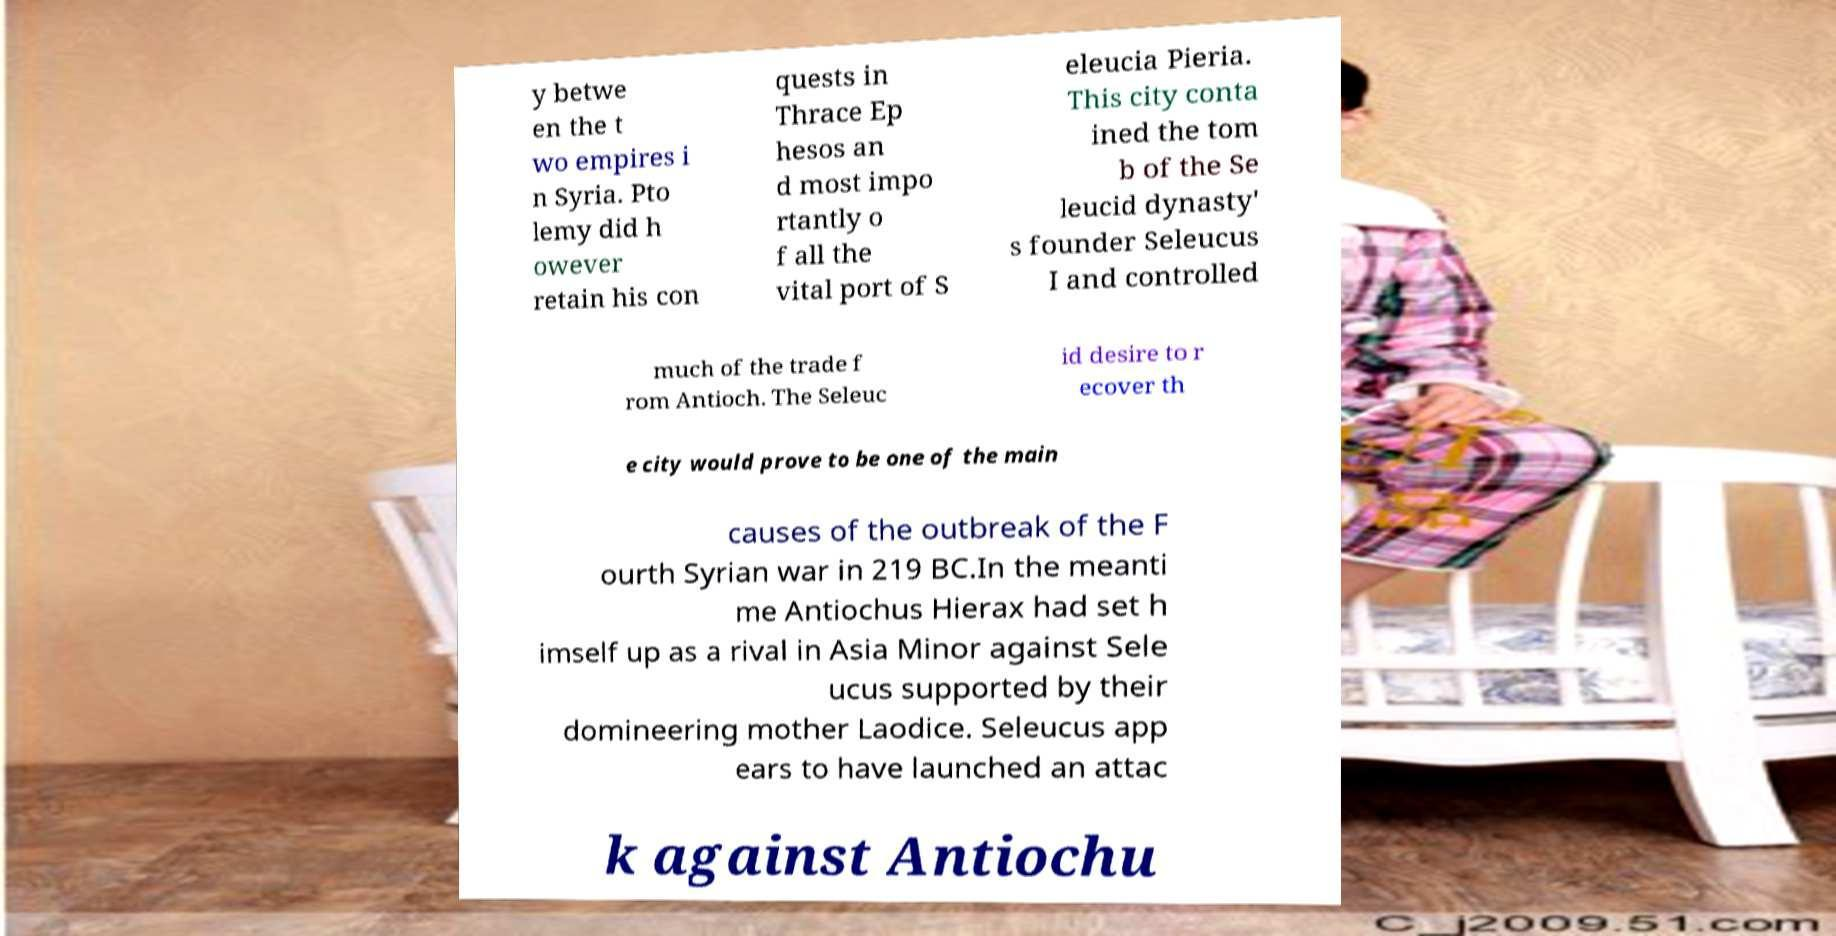There's text embedded in this image that I need extracted. Can you transcribe it verbatim? y betwe en the t wo empires i n Syria. Pto lemy did h owever retain his con quests in Thrace Ep hesos an d most impo rtantly o f all the vital port of S eleucia Pieria. This city conta ined the tom b of the Se leucid dynasty' s founder Seleucus I and controlled much of the trade f rom Antioch. The Seleuc id desire to r ecover th e city would prove to be one of the main causes of the outbreak of the F ourth Syrian war in 219 BC.In the meanti me Antiochus Hierax had set h imself up as a rival in Asia Minor against Sele ucus supported by their domineering mother Laodice. Seleucus app ears to have launched an attac k against Antiochu 